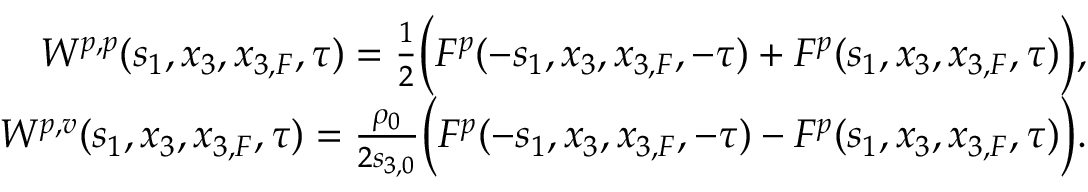<formula> <loc_0><loc_0><loc_500><loc_500>\begin{array} { r l r } & { W ^ { p , p } ( s _ { 1 } , x _ { 3 } , x _ { 3 , F } , \tau ) = \frac { 1 } { 2 } \left ( F ^ { p } ( - s _ { 1 } , x _ { 3 } , x _ { 3 , F } , - \tau ) + F ^ { p } ( s _ { 1 } , x _ { 3 } , x _ { 3 , F } , \tau ) \right ) , } \\ & { W ^ { p , v } ( s _ { 1 } , x _ { 3 } , x _ { 3 , F } , \tau ) = \frac { \rho _ { 0 } } { 2 s _ { 3 , 0 } } \left ( F ^ { p } ( - s _ { 1 } , x _ { 3 } , x _ { 3 , F } , - \tau ) - F ^ { p } ( s _ { 1 } , x _ { 3 } , x _ { 3 , F } , \tau ) \right ) . } \end{array}</formula> 